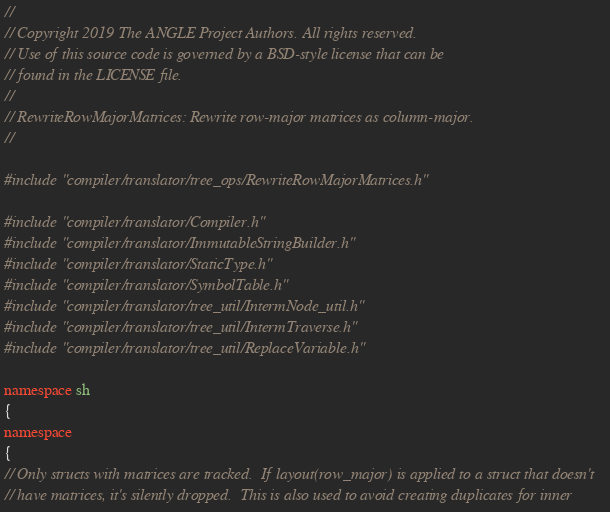Convert code to text. <code><loc_0><loc_0><loc_500><loc_500><_C++_>//
// Copyright 2019 The ANGLE Project Authors. All rights reserved.
// Use of this source code is governed by a BSD-style license that can be
// found in the LICENSE file.
//
// RewriteRowMajorMatrices: Rewrite row-major matrices as column-major.
//

#include "compiler/translator/tree_ops/RewriteRowMajorMatrices.h"

#include "compiler/translator/Compiler.h"
#include "compiler/translator/ImmutableStringBuilder.h"
#include "compiler/translator/StaticType.h"
#include "compiler/translator/SymbolTable.h"
#include "compiler/translator/tree_util/IntermNode_util.h"
#include "compiler/translator/tree_util/IntermTraverse.h"
#include "compiler/translator/tree_util/ReplaceVariable.h"

namespace sh
{
namespace
{
// Only structs with matrices are tracked.  If layout(row_major) is applied to a struct that doesn't
// have matrices, it's silently dropped.  This is also used to avoid creating duplicates for inner</code> 